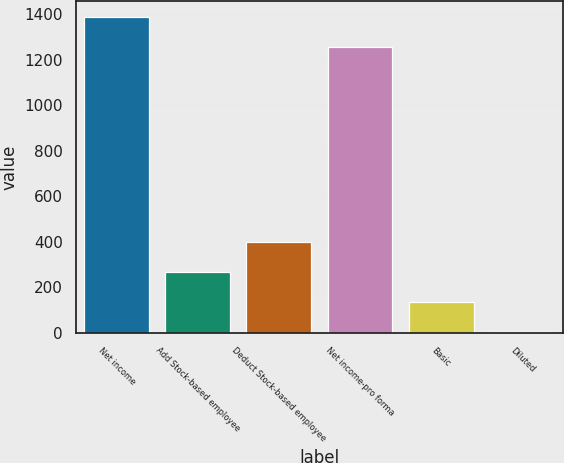Convert chart to OTSL. <chart><loc_0><loc_0><loc_500><loc_500><bar_chart><fcel>Net income<fcel>Add Stock-based employee<fcel>Deduct Stock-based employee<fcel>Net income-pro forma<fcel>Basic<fcel>Diluted<nl><fcel>1387.64<fcel>266.85<fcel>399.5<fcel>1255<fcel>134.2<fcel>1.55<nl></chart> 